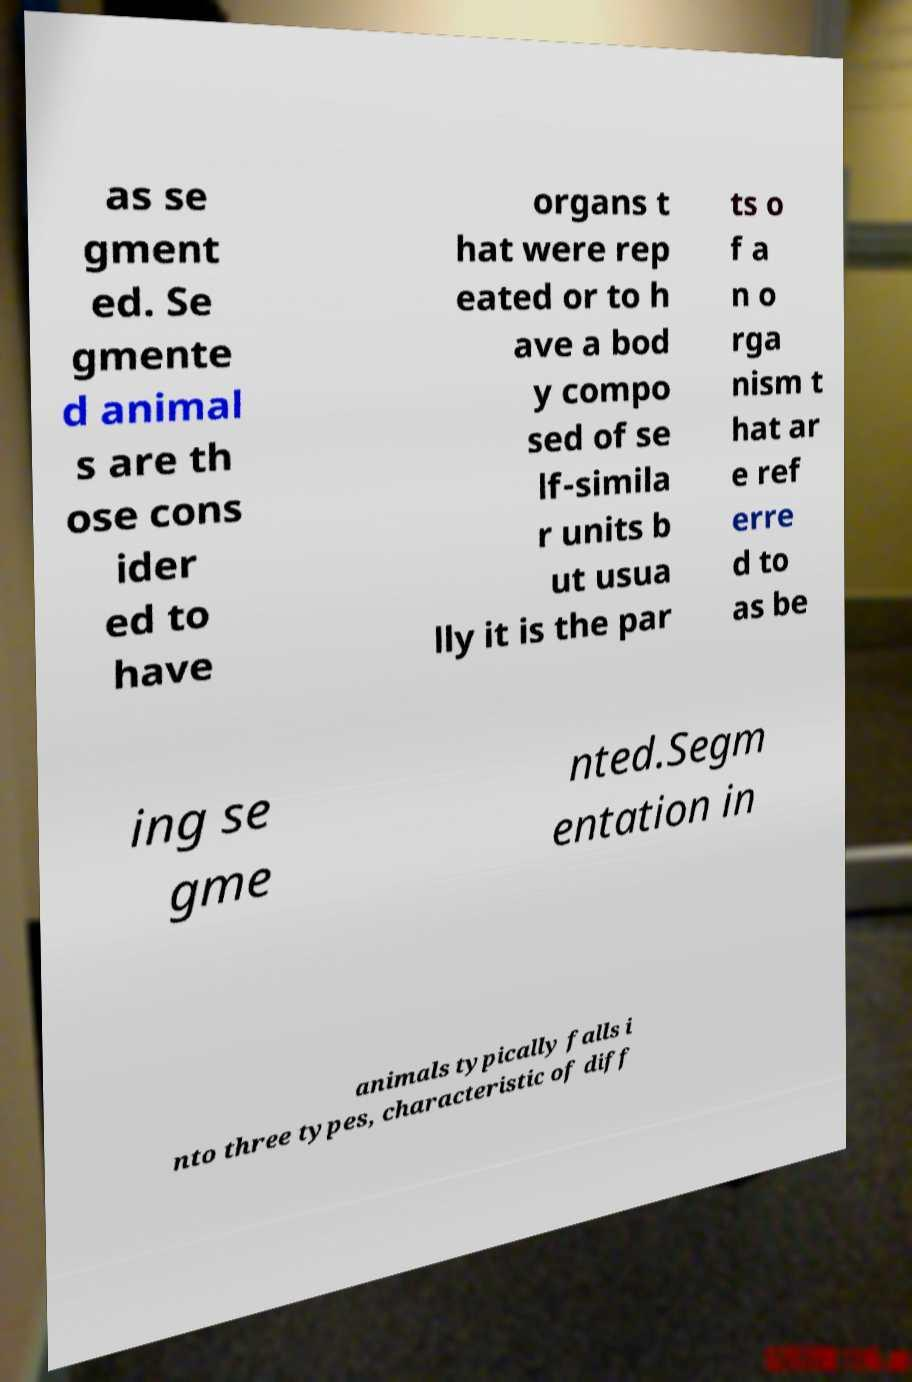Can you accurately transcribe the text from the provided image for me? as se gment ed. Se gmente d animal s are th ose cons ider ed to have organs t hat were rep eated or to h ave a bod y compo sed of se lf-simila r units b ut usua lly it is the par ts o f a n o rga nism t hat ar e ref erre d to as be ing se gme nted.Segm entation in animals typically falls i nto three types, characteristic of diff 